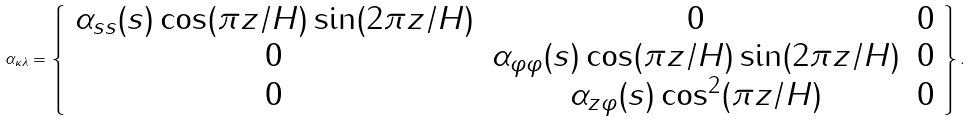Convert formula to latex. <formula><loc_0><loc_0><loc_500><loc_500>\alpha _ { \kappa \lambda } = \left \{ \begin{array} { c c c } \alpha _ { s s } ( s ) \cos ( \pi z / H ) \sin ( 2 \pi z / H ) & 0 & 0 \\ 0 & \alpha _ { \varphi \varphi } ( s ) \cos ( \pi z / H ) \sin ( 2 \pi z / H ) & 0 \\ 0 & \alpha _ { z \varphi } ( s ) \cos ^ { 2 } ( \pi z / H ) & 0 \end{array} \right \} .</formula> 